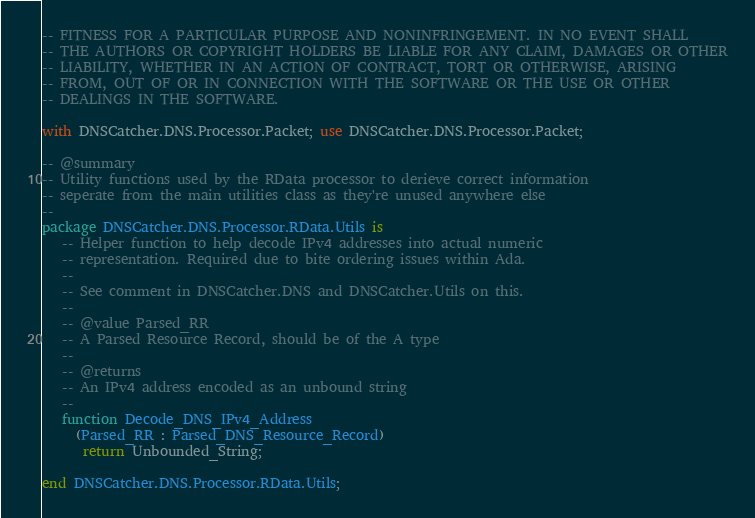<code> <loc_0><loc_0><loc_500><loc_500><_Ada_>-- FITNESS FOR A PARTICULAR PURPOSE AND NONINFRINGEMENT. IN NO EVENT SHALL
-- THE AUTHORS OR COPYRIGHT HOLDERS BE LIABLE FOR ANY CLAIM, DAMAGES OR OTHER
-- LIABILITY, WHETHER IN AN ACTION OF CONTRACT, TORT OR OTHERWISE, ARISING
-- FROM, OUT OF OR IN CONNECTION WITH THE SOFTWARE OR THE USE OR OTHER
-- DEALINGS IN THE SOFTWARE.

with DNSCatcher.DNS.Processor.Packet; use DNSCatcher.DNS.Processor.Packet;

-- @summary
-- Utility functions used by the RData processor to derieve correct information
-- seperate from the main utilities class as they're unused anywhere else
--
package DNSCatcher.DNS.Processor.RData.Utils is
   -- Helper function to help decode IPv4 addresses into actual numeric
   -- representation. Required due to bite ordering issues within Ada.
   --
   -- See comment in DNSCatcher.DNS and DNSCatcher.Utils on this.
   --
   -- @value Parsed_RR
   -- A Parsed Resource Record, should be of the A type
   --
   -- @returns
   -- An IPv4 address encoded as an unbound string
   --
   function Decode_DNS_IPv4_Address
     (Parsed_RR : Parsed_DNS_Resource_Record)
      return Unbounded_String;

end DNSCatcher.DNS.Processor.RData.Utils;
</code> 